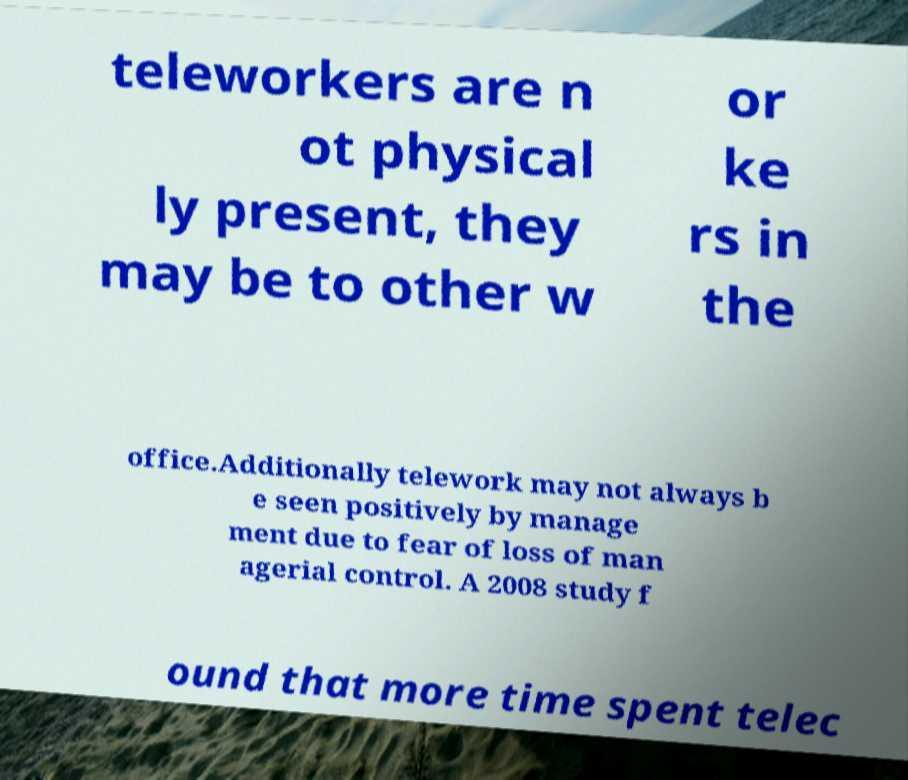Could you assist in decoding the text presented in this image and type it out clearly? teleworkers are n ot physical ly present, they may be to other w or ke rs in the office.Additionally telework may not always b e seen positively by manage ment due to fear of loss of man agerial control. A 2008 study f ound that more time spent telec 